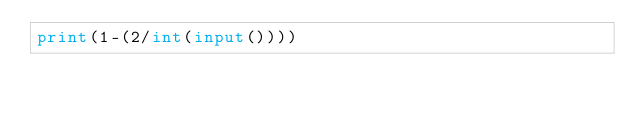<code> <loc_0><loc_0><loc_500><loc_500><_Python_>print(1-(2/int(input())))</code> 